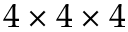Convert formula to latex. <formula><loc_0><loc_0><loc_500><loc_500>4 \times 4 \times 4</formula> 